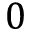<formula> <loc_0><loc_0><loc_500><loc_500>0</formula> 